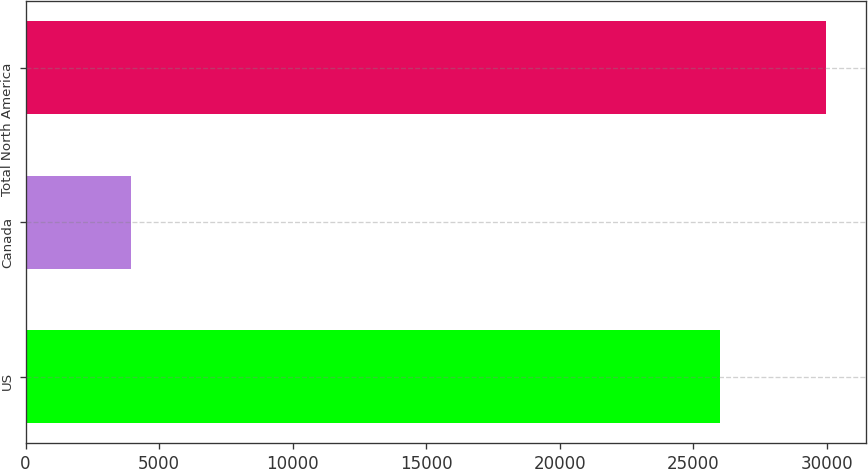<chart> <loc_0><loc_0><loc_500><loc_500><bar_chart><fcel>US<fcel>Canada<fcel>Total North America<nl><fcel>26025<fcel>3962<fcel>29987<nl></chart> 